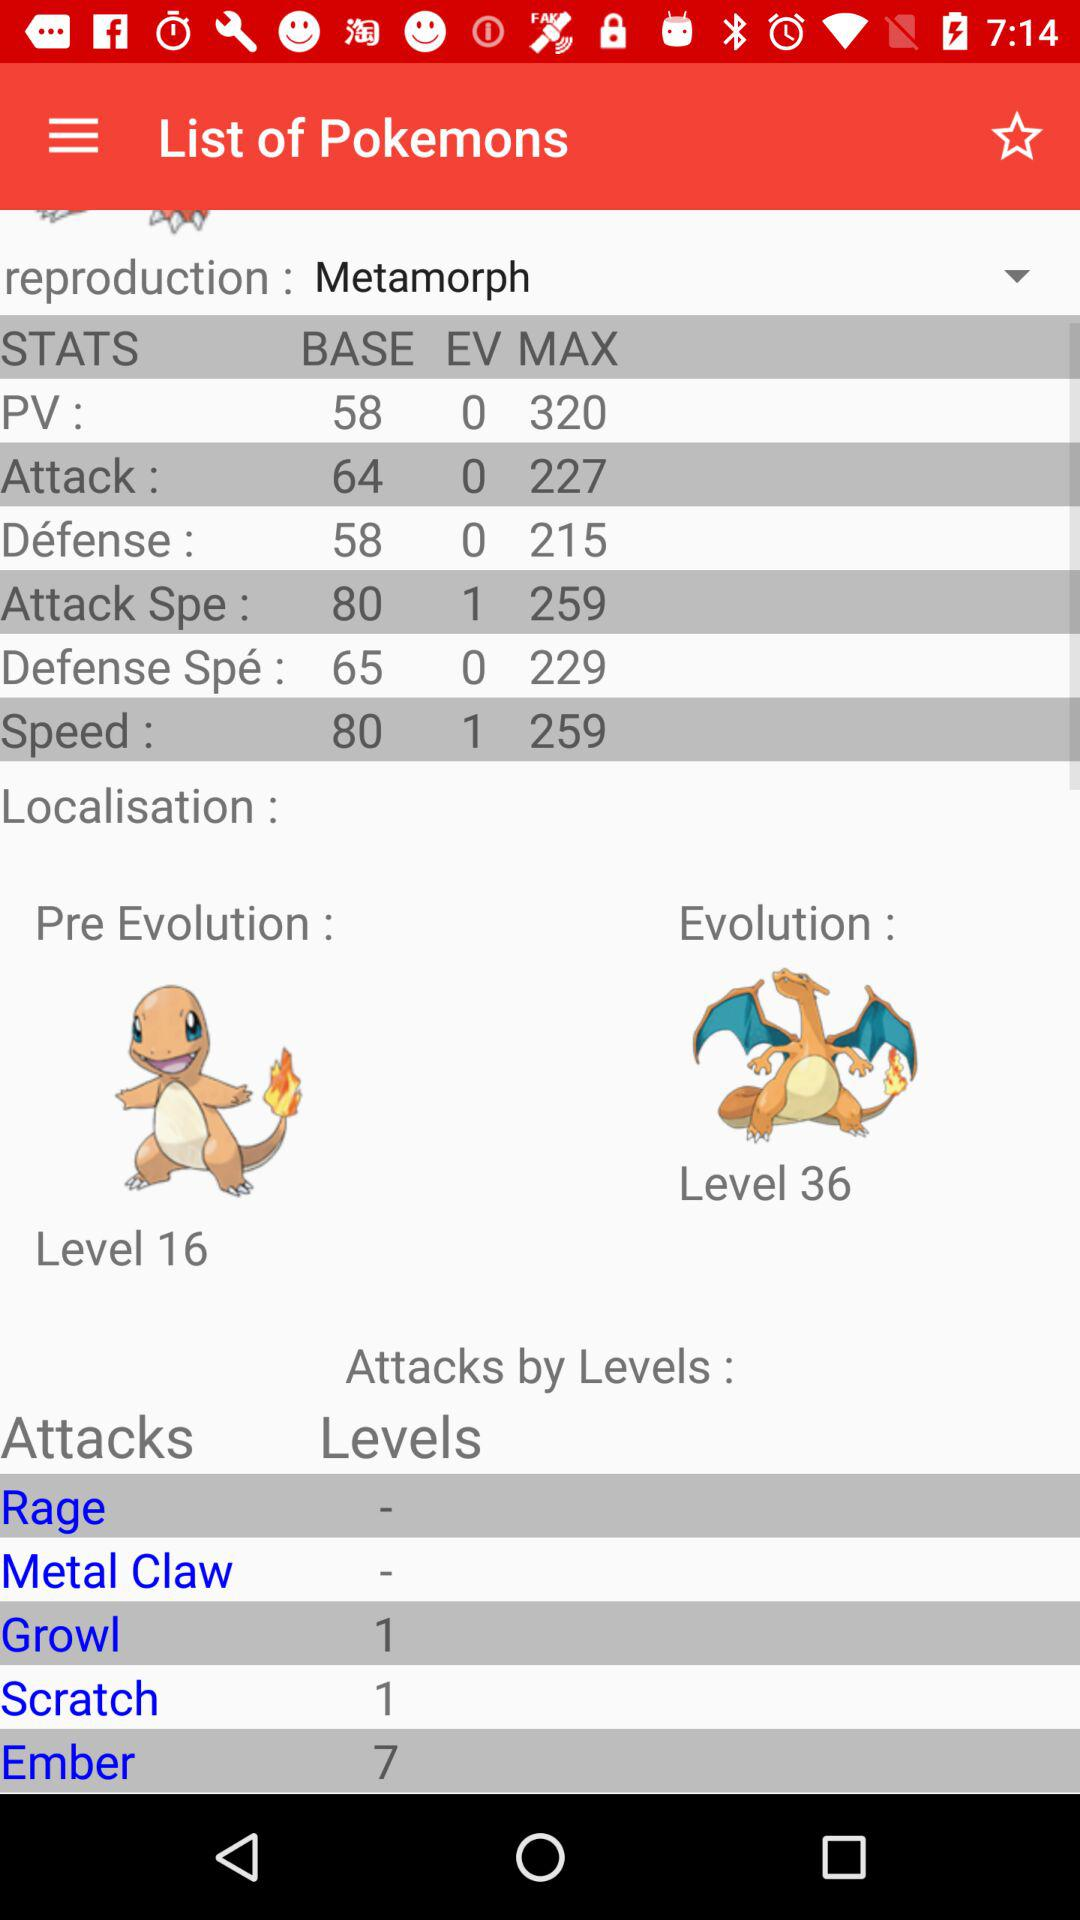What is the max. speed of "Metamorph"? The max. speed is 259. 